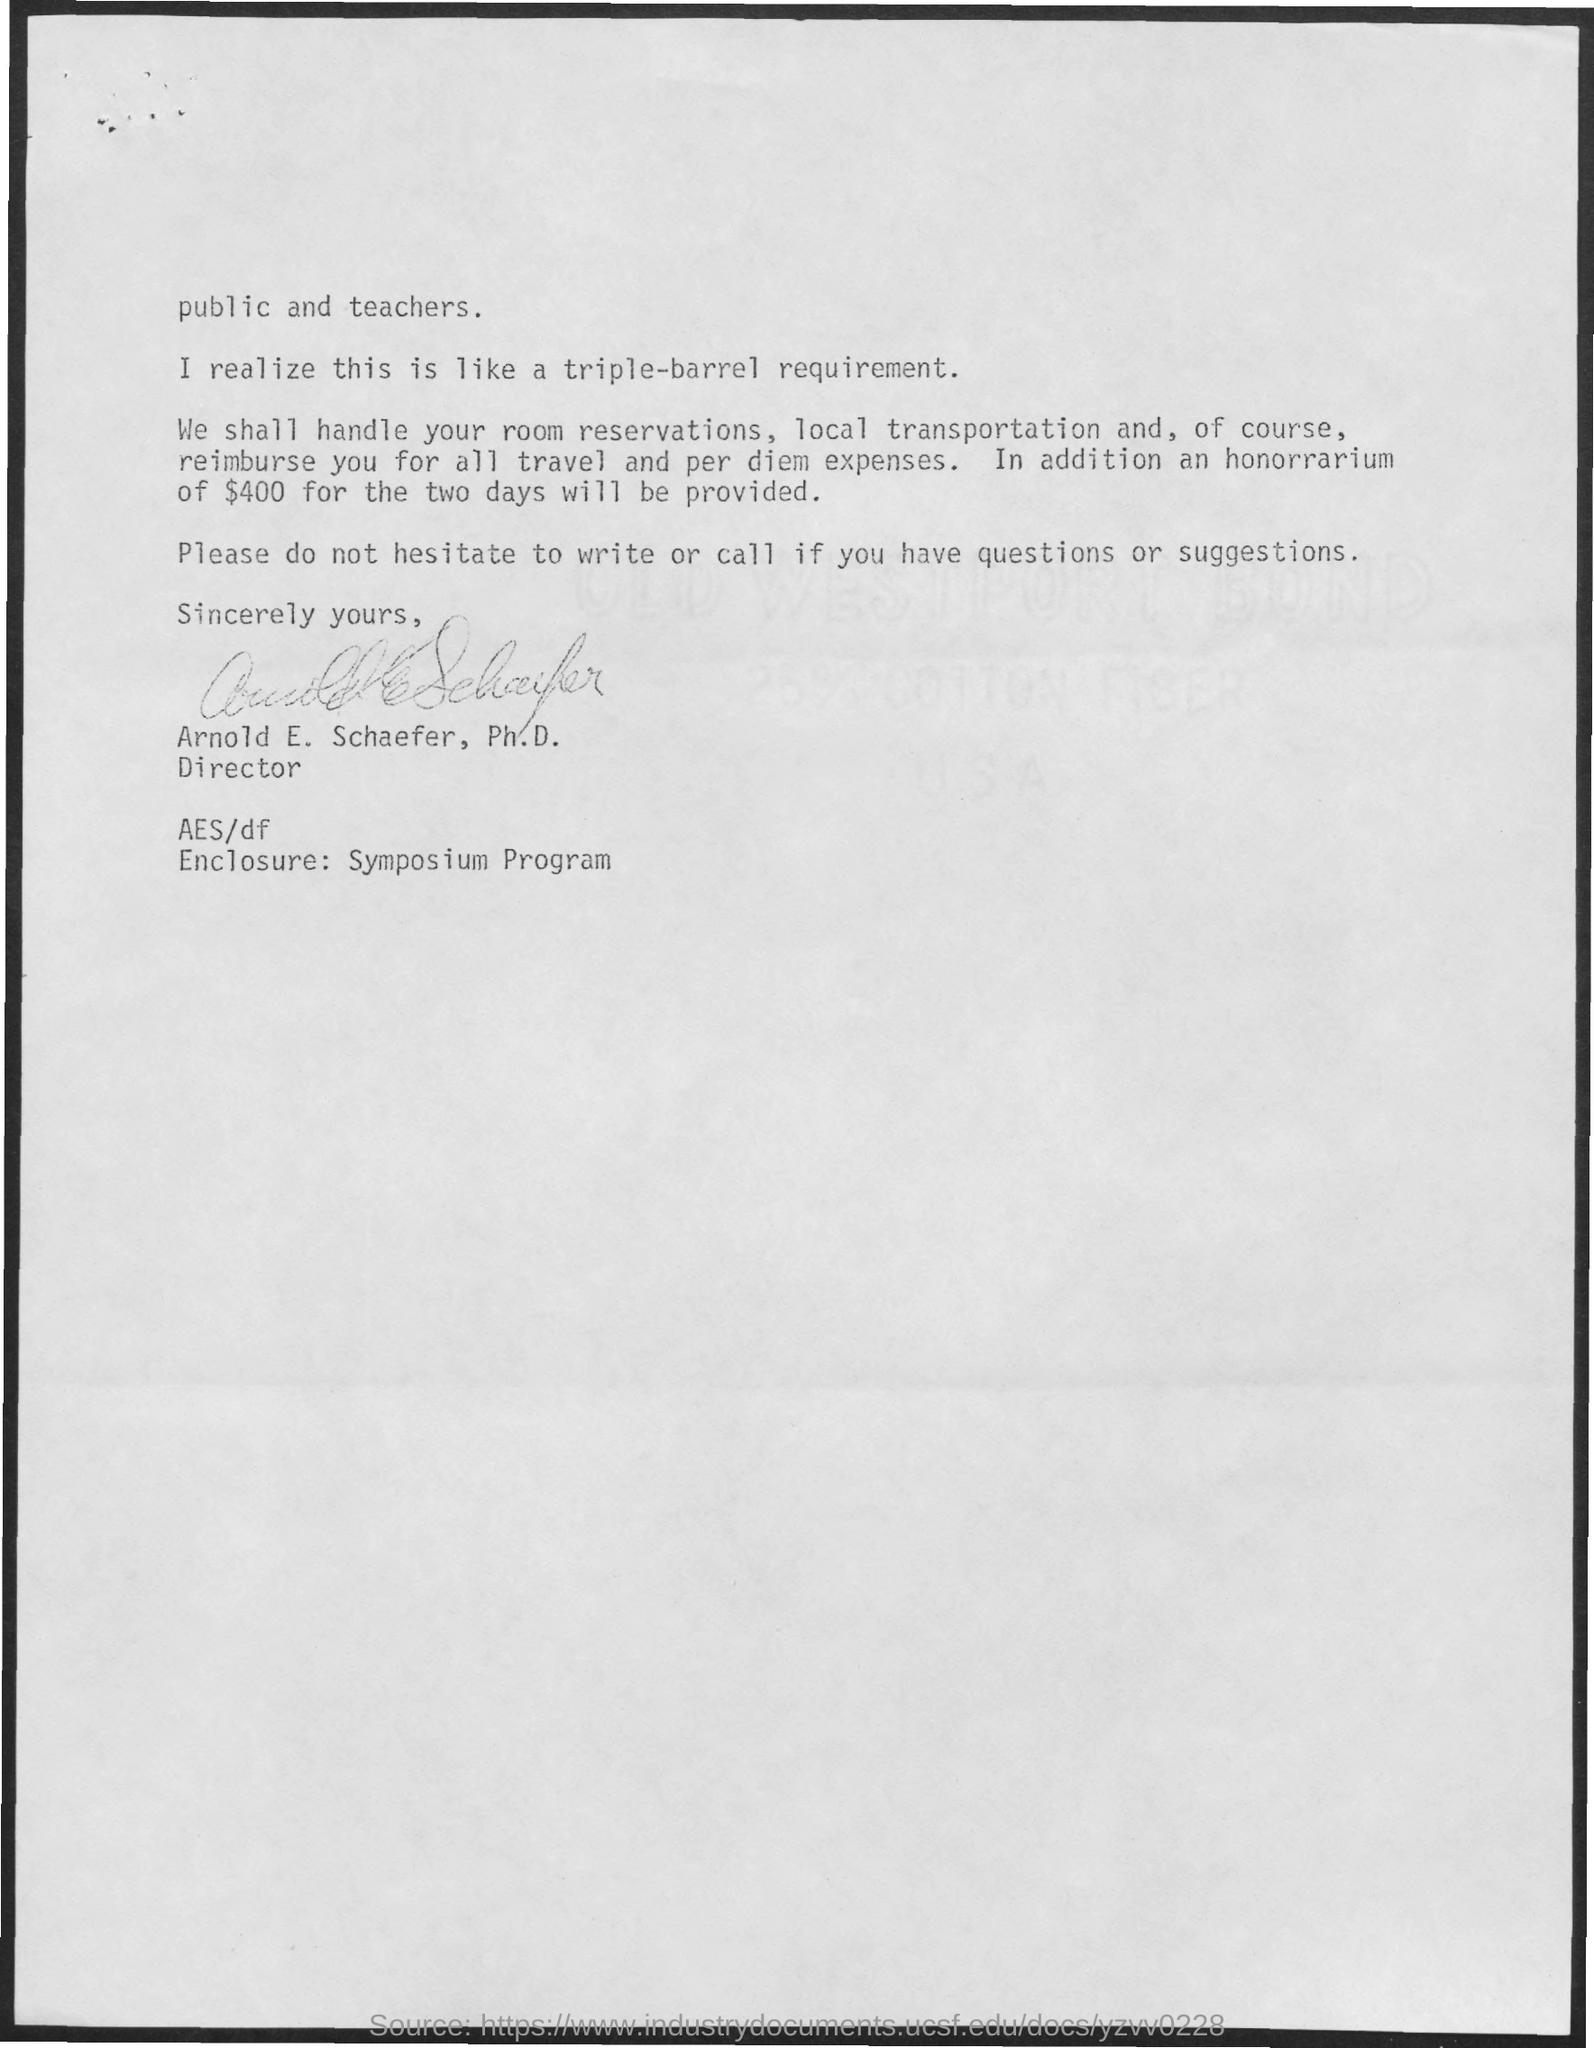Give some essential details in this illustration. I will be provided with an honorarium of $400 for two days of work. The letter has been signed by Arnold E. Schaefer, Ph.D. The symposium program for "What is the enclosure?" is now available. 